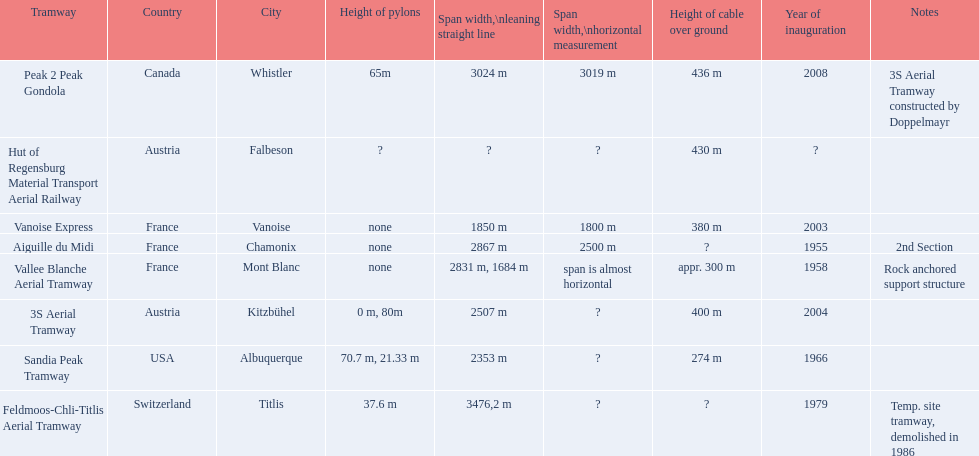When did the aiguille du midi tramway officially open? 1955. When was the 3s aerial tramway's inauguration? 2004. Which of them was inaugurated first? Aiguille du Midi. 